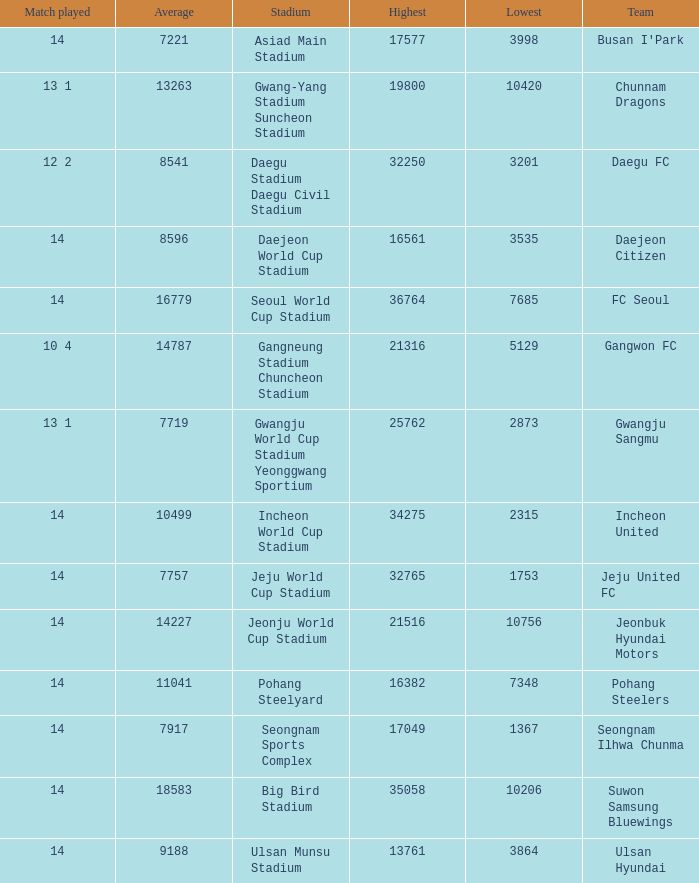How many match played have the highest as 32250? 12 2. 